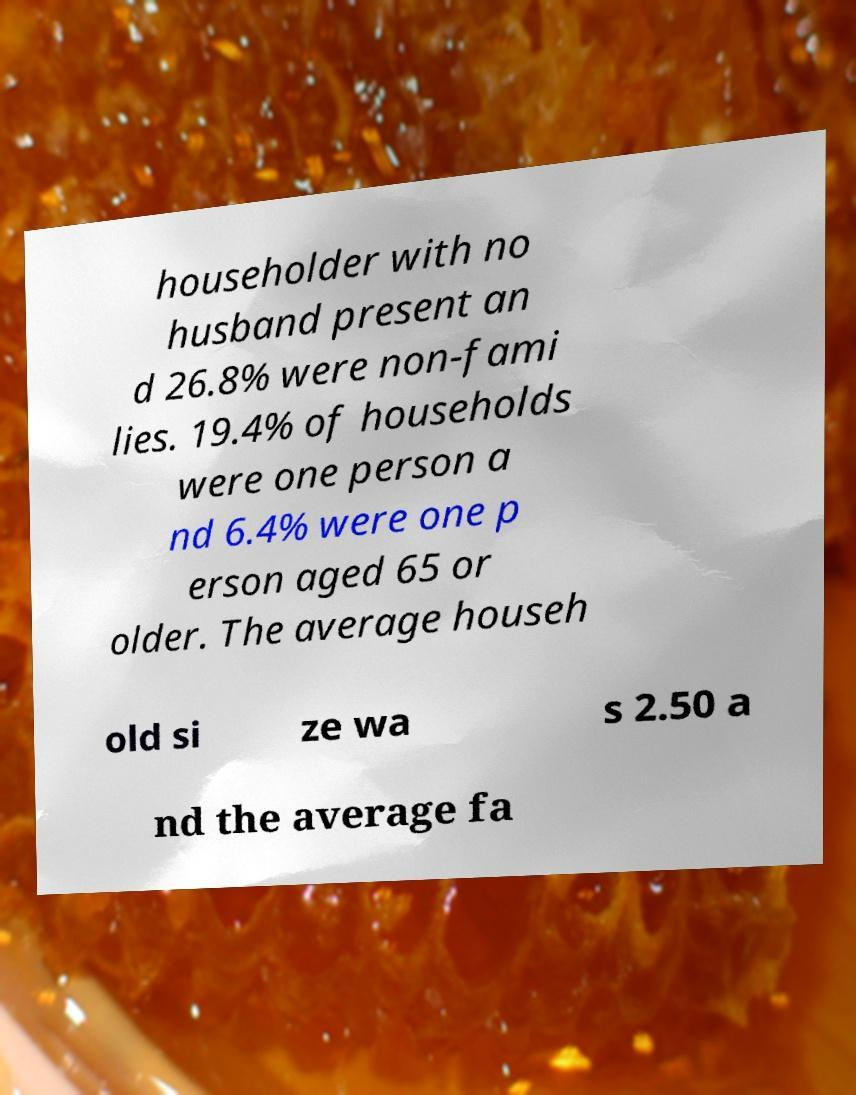Can you read and provide the text displayed in the image?This photo seems to have some interesting text. Can you extract and type it out for me? householder with no husband present an d 26.8% were non-fami lies. 19.4% of households were one person a nd 6.4% were one p erson aged 65 or older. The average househ old si ze wa s 2.50 a nd the average fa 